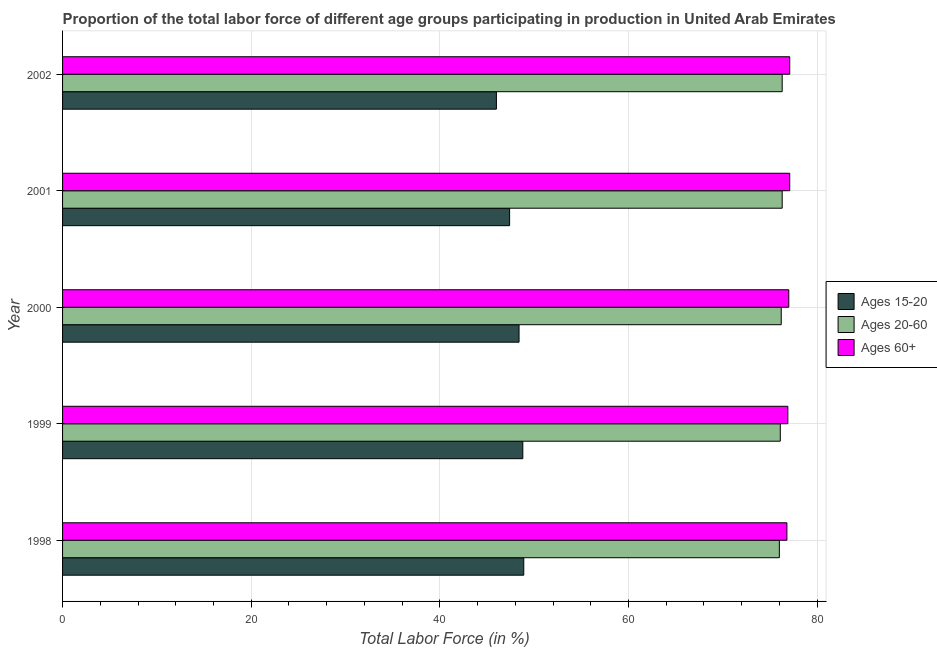How many different coloured bars are there?
Offer a terse response. 3. How many groups of bars are there?
Offer a terse response. 5. Are the number of bars on each tick of the Y-axis equal?
Give a very brief answer. Yes. How many bars are there on the 2nd tick from the top?
Ensure brevity in your answer.  3. How many bars are there on the 5th tick from the bottom?
Keep it short and to the point. 3. What is the percentage of labor force within the age group 20-60 in 1999?
Your answer should be compact. 76.1. Across all years, what is the maximum percentage of labor force above age 60?
Provide a succinct answer. 77.1. Across all years, what is the minimum percentage of labor force above age 60?
Offer a terse response. 76.8. In which year was the percentage of labor force within the age group 15-20 maximum?
Offer a terse response. 1998. What is the total percentage of labor force within the age group 15-20 in the graph?
Ensure brevity in your answer.  239.5. What is the difference between the percentage of labor force within the age group 20-60 in 2001 and the percentage of labor force within the age group 15-20 in 1998?
Ensure brevity in your answer.  27.4. What is the average percentage of labor force within the age group 20-60 per year?
Ensure brevity in your answer.  76.18. In the year 1998, what is the difference between the percentage of labor force within the age group 20-60 and percentage of labor force within the age group 15-20?
Offer a terse response. 27.1. In how many years, is the percentage of labor force above age 60 greater than 40 %?
Your answer should be very brief. 5. What is the ratio of the percentage of labor force within the age group 15-20 in 1998 to that in 2001?
Your answer should be compact. 1.03. What is the difference between the highest and the second highest percentage of labor force above age 60?
Offer a very short reply. 0. Is the sum of the percentage of labor force within the age group 15-20 in 1998 and 1999 greater than the maximum percentage of labor force within the age group 20-60 across all years?
Make the answer very short. Yes. What does the 3rd bar from the top in 1998 represents?
Keep it short and to the point. Ages 15-20. What does the 1st bar from the bottom in 1998 represents?
Your answer should be very brief. Ages 15-20. How many bars are there?
Keep it short and to the point. 15. Are all the bars in the graph horizontal?
Offer a very short reply. Yes. Does the graph contain grids?
Keep it short and to the point. Yes. Where does the legend appear in the graph?
Make the answer very short. Center right. How are the legend labels stacked?
Make the answer very short. Vertical. What is the title of the graph?
Give a very brief answer. Proportion of the total labor force of different age groups participating in production in United Arab Emirates. Does "Czech Republic" appear as one of the legend labels in the graph?
Provide a short and direct response. No. What is the label or title of the Y-axis?
Make the answer very short. Year. What is the Total Labor Force (in %) in Ages 15-20 in 1998?
Ensure brevity in your answer.  48.9. What is the Total Labor Force (in %) of Ages 60+ in 1998?
Keep it short and to the point. 76.8. What is the Total Labor Force (in %) of Ages 15-20 in 1999?
Your answer should be compact. 48.8. What is the Total Labor Force (in %) in Ages 20-60 in 1999?
Provide a short and direct response. 76.1. What is the Total Labor Force (in %) in Ages 60+ in 1999?
Provide a succinct answer. 76.9. What is the Total Labor Force (in %) in Ages 15-20 in 2000?
Give a very brief answer. 48.4. What is the Total Labor Force (in %) in Ages 20-60 in 2000?
Offer a terse response. 76.2. What is the Total Labor Force (in %) in Ages 60+ in 2000?
Offer a terse response. 77. What is the Total Labor Force (in %) of Ages 15-20 in 2001?
Give a very brief answer. 47.4. What is the Total Labor Force (in %) of Ages 20-60 in 2001?
Your answer should be compact. 76.3. What is the Total Labor Force (in %) of Ages 60+ in 2001?
Your answer should be compact. 77.1. What is the Total Labor Force (in %) in Ages 20-60 in 2002?
Keep it short and to the point. 76.3. What is the Total Labor Force (in %) in Ages 60+ in 2002?
Make the answer very short. 77.1. Across all years, what is the maximum Total Labor Force (in %) of Ages 15-20?
Offer a very short reply. 48.9. Across all years, what is the maximum Total Labor Force (in %) of Ages 20-60?
Give a very brief answer. 76.3. Across all years, what is the maximum Total Labor Force (in %) in Ages 60+?
Your answer should be very brief. 77.1. Across all years, what is the minimum Total Labor Force (in %) of Ages 15-20?
Make the answer very short. 46. Across all years, what is the minimum Total Labor Force (in %) of Ages 20-60?
Provide a short and direct response. 76. Across all years, what is the minimum Total Labor Force (in %) of Ages 60+?
Ensure brevity in your answer.  76.8. What is the total Total Labor Force (in %) of Ages 15-20 in the graph?
Offer a very short reply. 239.5. What is the total Total Labor Force (in %) of Ages 20-60 in the graph?
Offer a terse response. 380.9. What is the total Total Labor Force (in %) in Ages 60+ in the graph?
Your response must be concise. 384.9. What is the difference between the Total Labor Force (in %) in Ages 15-20 in 1998 and that in 1999?
Provide a succinct answer. 0.1. What is the difference between the Total Labor Force (in %) in Ages 15-20 in 1998 and that in 2000?
Your answer should be very brief. 0.5. What is the difference between the Total Labor Force (in %) in Ages 60+ in 1998 and that in 2000?
Keep it short and to the point. -0.2. What is the difference between the Total Labor Force (in %) in Ages 60+ in 1998 and that in 2001?
Your answer should be very brief. -0.3. What is the difference between the Total Labor Force (in %) of Ages 15-20 in 1998 and that in 2002?
Provide a succinct answer. 2.9. What is the difference between the Total Labor Force (in %) of Ages 60+ in 1998 and that in 2002?
Provide a short and direct response. -0.3. What is the difference between the Total Labor Force (in %) in Ages 15-20 in 1999 and that in 2000?
Your response must be concise. 0.4. What is the difference between the Total Labor Force (in %) in Ages 60+ in 1999 and that in 2000?
Provide a succinct answer. -0.1. What is the difference between the Total Labor Force (in %) in Ages 15-20 in 1999 and that in 2001?
Give a very brief answer. 1.4. What is the difference between the Total Labor Force (in %) of Ages 20-60 in 1999 and that in 2001?
Your response must be concise. -0.2. What is the difference between the Total Labor Force (in %) in Ages 60+ in 1999 and that in 2001?
Keep it short and to the point. -0.2. What is the difference between the Total Labor Force (in %) of Ages 15-20 in 1999 and that in 2002?
Keep it short and to the point. 2.8. What is the difference between the Total Labor Force (in %) in Ages 20-60 in 1999 and that in 2002?
Keep it short and to the point. -0.2. What is the difference between the Total Labor Force (in %) of Ages 60+ in 1999 and that in 2002?
Your answer should be very brief. -0.2. What is the difference between the Total Labor Force (in %) of Ages 20-60 in 2000 and that in 2001?
Give a very brief answer. -0.1. What is the difference between the Total Labor Force (in %) of Ages 60+ in 2000 and that in 2002?
Provide a succinct answer. -0.1. What is the difference between the Total Labor Force (in %) of Ages 15-20 in 2001 and that in 2002?
Offer a very short reply. 1.4. What is the difference between the Total Labor Force (in %) of Ages 20-60 in 2001 and that in 2002?
Provide a short and direct response. 0. What is the difference between the Total Labor Force (in %) of Ages 15-20 in 1998 and the Total Labor Force (in %) of Ages 20-60 in 1999?
Keep it short and to the point. -27.2. What is the difference between the Total Labor Force (in %) in Ages 20-60 in 1998 and the Total Labor Force (in %) in Ages 60+ in 1999?
Provide a succinct answer. -0.9. What is the difference between the Total Labor Force (in %) in Ages 15-20 in 1998 and the Total Labor Force (in %) in Ages 20-60 in 2000?
Your answer should be very brief. -27.3. What is the difference between the Total Labor Force (in %) of Ages 15-20 in 1998 and the Total Labor Force (in %) of Ages 60+ in 2000?
Provide a succinct answer. -28.1. What is the difference between the Total Labor Force (in %) in Ages 20-60 in 1998 and the Total Labor Force (in %) in Ages 60+ in 2000?
Keep it short and to the point. -1. What is the difference between the Total Labor Force (in %) of Ages 15-20 in 1998 and the Total Labor Force (in %) of Ages 20-60 in 2001?
Offer a terse response. -27.4. What is the difference between the Total Labor Force (in %) of Ages 15-20 in 1998 and the Total Labor Force (in %) of Ages 60+ in 2001?
Make the answer very short. -28.2. What is the difference between the Total Labor Force (in %) of Ages 15-20 in 1998 and the Total Labor Force (in %) of Ages 20-60 in 2002?
Offer a very short reply. -27.4. What is the difference between the Total Labor Force (in %) in Ages 15-20 in 1998 and the Total Labor Force (in %) in Ages 60+ in 2002?
Your response must be concise. -28.2. What is the difference between the Total Labor Force (in %) in Ages 15-20 in 1999 and the Total Labor Force (in %) in Ages 20-60 in 2000?
Keep it short and to the point. -27.4. What is the difference between the Total Labor Force (in %) in Ages 15-20 in 1999 and the Total Labor Force (in %) in Ages 60+ in 2000?
Your answer should be compact. -28.2. What is the difference between the Total Labor Force (in %) in Ages 15-20 in 1999 and the Total Labor Force (in %) in Ages 20-60 in 2001?
Give a very brief answer. -27.5. What is the difference between the Total Labor Force (in %) in Ages 15-20 in 1999 and the Total Labor Force (in %) in Ages 60+ in 2001?
Provide a succinct answer. -28.3. What is the difference between the Total Labor Force (in %) of Ages 15-20 in 1999 and the Total Labor Force (in %) of Ages 20-60 in 2002?
Your response must be concise. -27.5. What is the difference between the Total Labor Force (in %) in Ages 15-20 in 1999 and the Total Labor Force (in %) in Ages 60+ in 2002?
Ensure brevity in your answer.  -28.3. What is the difference between the Total Labor Force (in %) in Ages 15-20 in 2000 and the Total Labor Force (in %) in Ages 20-60 in 2001?
Offer a terse response. -27.9. What is the difference between the Total Labor Force (in %) in Ages 15-20 in 2000 and the Total Labor Force (in %) in Ages 60+ in 2001?
Provide a short and direct response. -28.7. What is the difference between the Total Labor Force (in %) of Ages 15-20 in 2000 and the Total Labor Force (in %) of Ages 20-60 in 2002?
Your response must be concise. -27.9. What is the difference between the Total Labor Force (in %) of Ages 15-20 in 2000 and the Total Labor Force (in %) of Ages 60+ in 2002?
Offer a very short reply. -28.7. What is the difference between the Total Labor Force (in %) in Ages 20-60 in 2000 and the Total Labor Force (in %) in Ages 60+ in 2002?
Offer a very short reply. -0.9. What is the difference between the Total Labor Force (in %) of Ages 15-20 in 2001 and the Total Labor Force (in %) of Ages 20-60 in 2002?
Ensure brevity in your answer.  -28.9. What is the difference between the Total Labor Force (in %) in Ages 15-20 in 2001 and the Total Labor Force (in %) in Ages 60+ in 2002?
Offer a very short reply. -29.7. What is the average Total Labor Force (in %) in Ages 15-20 per year?
Your answer should be very brief. 47.9. What is the average Total Labor Force (in %) in Ages 20-60 per year?
Provide a short and direct response. 76.18. What is the average Total Labor Force (in %) in Ages 60+ per year?
Offer a very short reply. 76.98. In the year 1998, what is the difference between the Total Labor Force (in %) in Ages 15-20 and Total Labor Force (in %) in Ages 20-60?
Keep it short and to the point. -27.1. In the year 1998, what is the difference between the Total Labor Force (in %) of Ages 15-20 and Total Labor Force (in %) of Ages 60+?
Give a very brief answer. -27.9. In the year 1998, what is the difference between the Total Labor Force (in %) in Ages 20-60 and Total Labor Force (in %) in Ages 60+?
Provide a succinct answer. -0.8. In the year 1999, what is the difference between the Total Labor Force (in %) of Ages 15-20 and Total Labor Force (in %) of Ages 20-60?
Make the answer very short. -27.3. In the year 1999, what is the difference between the Total Labor Force (in %) of Ages 15-20 and Total Labor Force (in %) of Ages 60+?
Offer a terse response. -28.1. In the year 2000, what is the difference between the Total Labor Force (in %) in Ages 15-20 and Total Labor Force (in %) in Ages 20-60?
Make the answer very short. -27.8. In the year 2000, what is the difference between the Total Labor Force (in %) of Ages 15-20 and Total Labor Force (in %) of Ages 60+?
Provide a succinct answer. -28.6. In the year 2001, what is the difference between the Total Labor Force (in %) of Ages 15-20 and Total Labor Force (in %) of Ages 20-60?
Ensure brevity in your answer.  -28.9. In the year 2001, what is the difference between the Total Labor Force (in %) of Ages 15-20 and Total Labor Force (in %) of Ages 60+?
Keep it short and to the point. -29.7. In the year 2002, what is the difference between the Total Labor Force (in %) in Ages 15-20 and Total Labor Force (in %) in Ages 20-60?
Ensure brevity in your answer.  -30.3. In the year 2002, what is the difference between the Total Labor Force (in %) of Ages 15-20 and Total Labor Force (in %) of Ages 60+?
Give a very brief answer. -31.1. What is the ratio of the Total Labor Force (in %) of Ages 20-60 in 1998 to that in 1999?
Keep it short and to the point. 1. What is the ratio of the Total Labor Force (in %) in Ages 15-20 in 1998 to that in 2000?
Your answer should be very brief. 1.01. What is the ratio of the Total Labor Force (in %) in Ages 20-60 in 1998 to that in 2000?
Offer a very short reply. 1. What is the ratio of the Total Labor Force (in %) of Ages 15-20 in 1998 to that in 2001?
Give a very brief answer. 1.03. What is the ratio of the Total Labor Force (in %) of Ages 15-20 in 1998 to that in 2002?
Keep it short and to the point. 1.06. What is the ratio of the Total Labor Force (in %) of Ages 15-20 in 1999 to that in 2000?
Your answer should be compact. 1.01. What is the ratio of the Total Labor Force (in %) of Ages 15-20 in 1999 to that in 2001?
Your answer should be very brief. 1.03. What is the ratio of the Total Labor Force (in %) of Ages 15-20 in 1999 to that in 2002?
Your answer should be compact. 1.06. What is the ratio of the Total Labor Force (in %) of Ages 20-60 in 1999 to that in 2002?
Your answer should be very brief. 1. What is the ratio of the Total Labor Force (in %) of Ages 15-20 in 2000 to that in 2001?
Ensure brevity in your answer.  1.02. What is the ratio of the Total Labor Force (in %) of Ages 15-20 in 2000 to that in 2002?
Give a very brief answer. 1.05. What is the ratio of the Total Labor Force (in %) of Ages 20-60 in 2000 to that in 2002?
Your answer should be very brief. 1. What is the ratio of the Total Labor Force (in %) of Ages 60+ in 2000 to that in 2002?
Ensure brevity in your answer.  1. What is the ratio of the Total Labor Force (in %) of Ages 15-20 in 2001 to that in 2002?
Offer a very short reply. 1.03. What is the ratio of the Total Labor Force (in %) in Ages 20-60 in 2001 to that in 2002?
Provide a succinct answer. 1. What is the ratio of the Total Labor Force (in %) in Ages 60+ in 2001 to that in 2002?
Offer a terse response. 1. What is the difference between the highest and the lowest Total Labor Force (in %) of Ages 60+?
Ensure brevity in your answer.  0.3. 